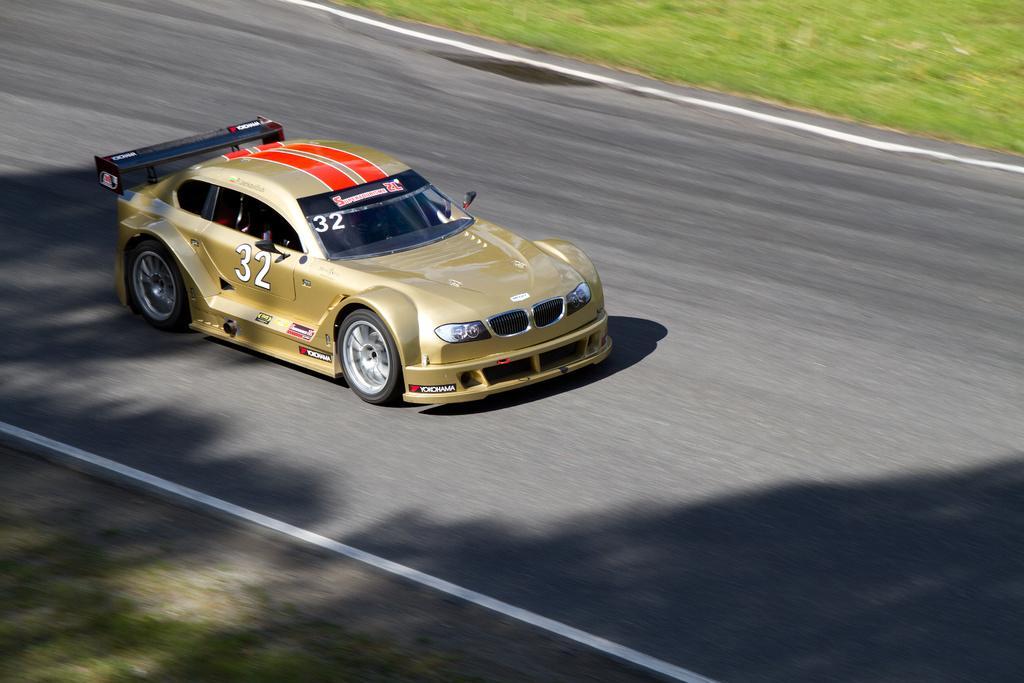Describe this image in one or two sentences. In this picture I can see there is a car moving on the road and there is some grass on two sides of the road. 